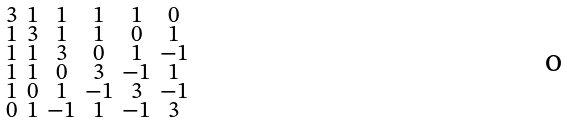<formula> <loc_0><loc_0><loc_500><loc_500>\begin{smallmatrix} 3 & 1 & 1 & 1 & 1 & 0 \\ 1 & 3 & 1 & 1 & 0 & 1 \\ 1 & 1 & 3 & 0 & 1 & - 1 \\ 1 & 1 & 0 & 3 & - 1 & 1 \\ 1 & 0 & 1 & - 1 & 3 & - 1 \\ 0 & 1 & - 1 & 1 & - 1 & 3 \end{smallmatrix}</formula> 